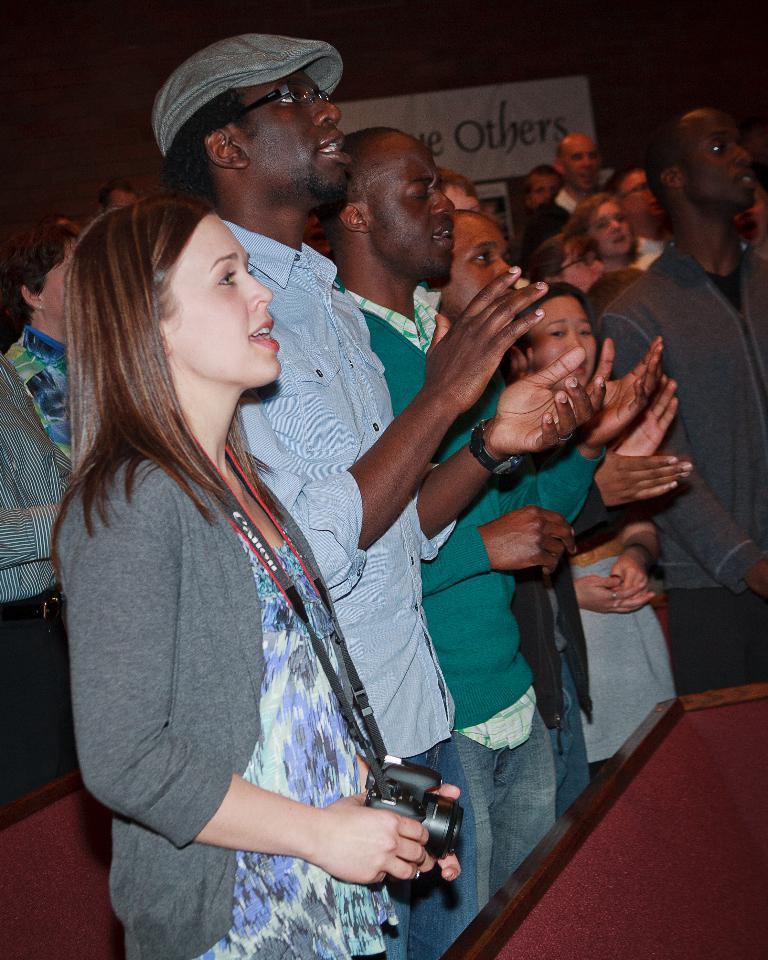Describe this image in one or two sentences. In this picture, we see people standing and clapping hands. In front of them, we see a table. The woman in grey jacket is holding a camera in her hands and she is singing the song. Behind them, we see a white board with some text written on it. It is dark in the background. 